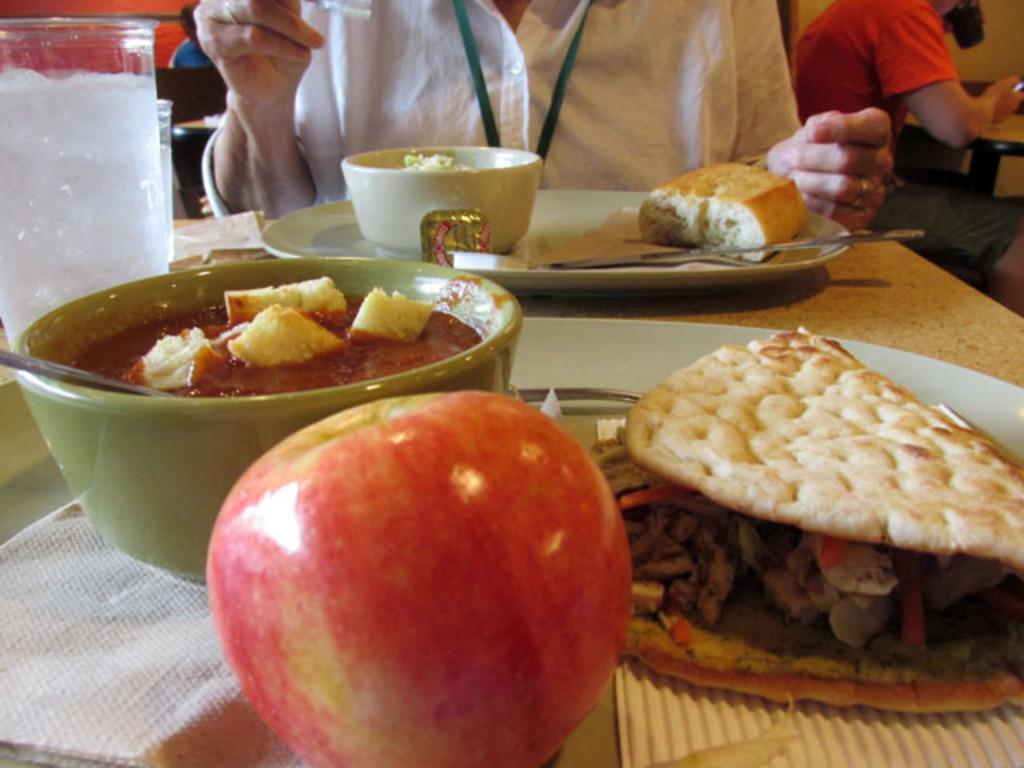Describe this image in one or two sentences. There are plates and a bowl, which contains food items and glasses, tissues, spoons and an apple on the table. There are people at the top side. 